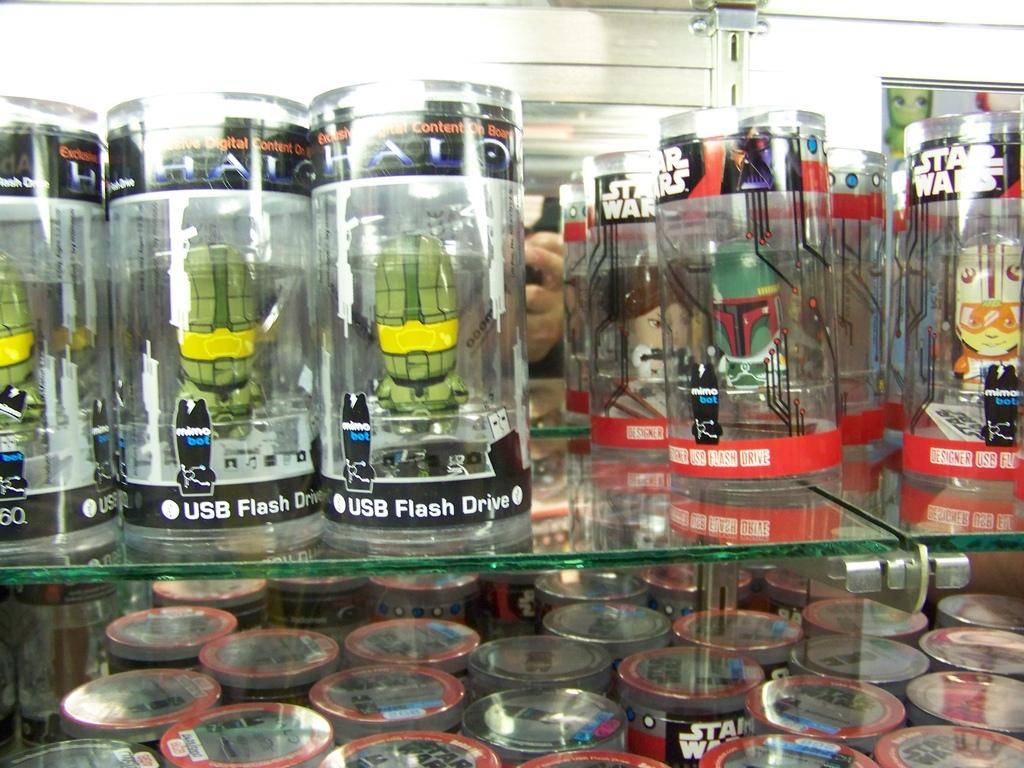<image>
Provide a brief description of the given image. Nija Turtle USB Flash drives sitting on the shelve with Star Wars USB drives. 